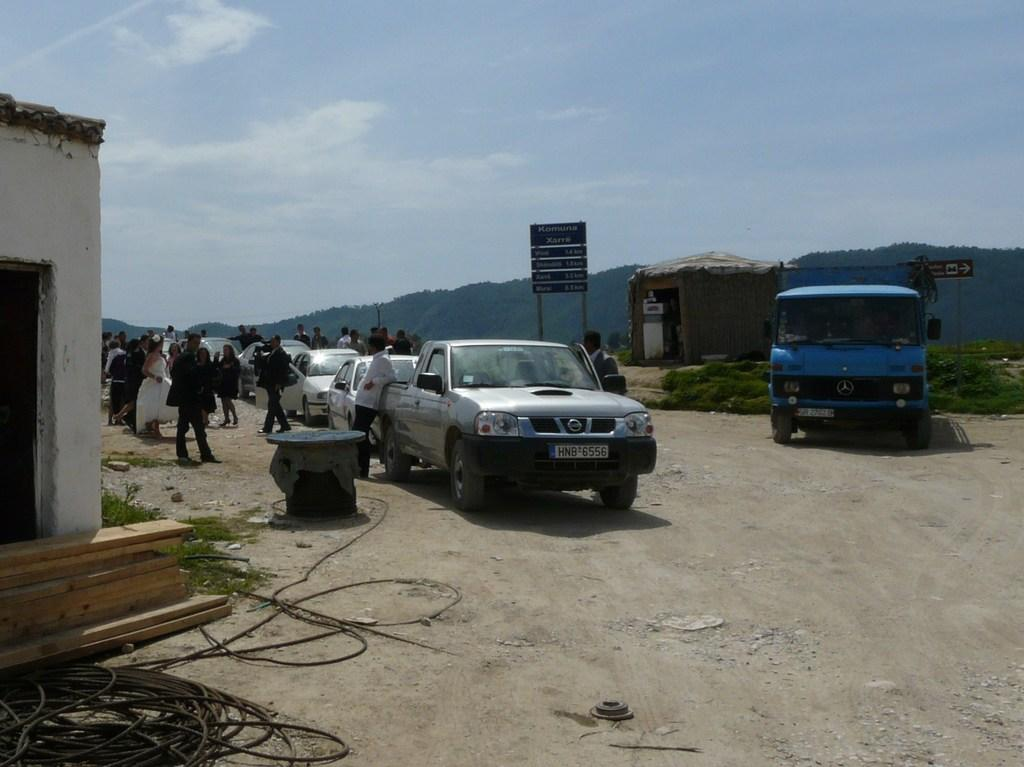What is happening on the road in the image? Vehicles are moving on the road. What are some people doing in the image? Some people are walking. What type of buildings can be seen in the image? There is a house and a hut visible. How much money is being exchanged between the people in the image? There is no indication of money being exchanged in the image. What type of sweater is the mother wearing in the image? There is no mother or sweater present in the image. 